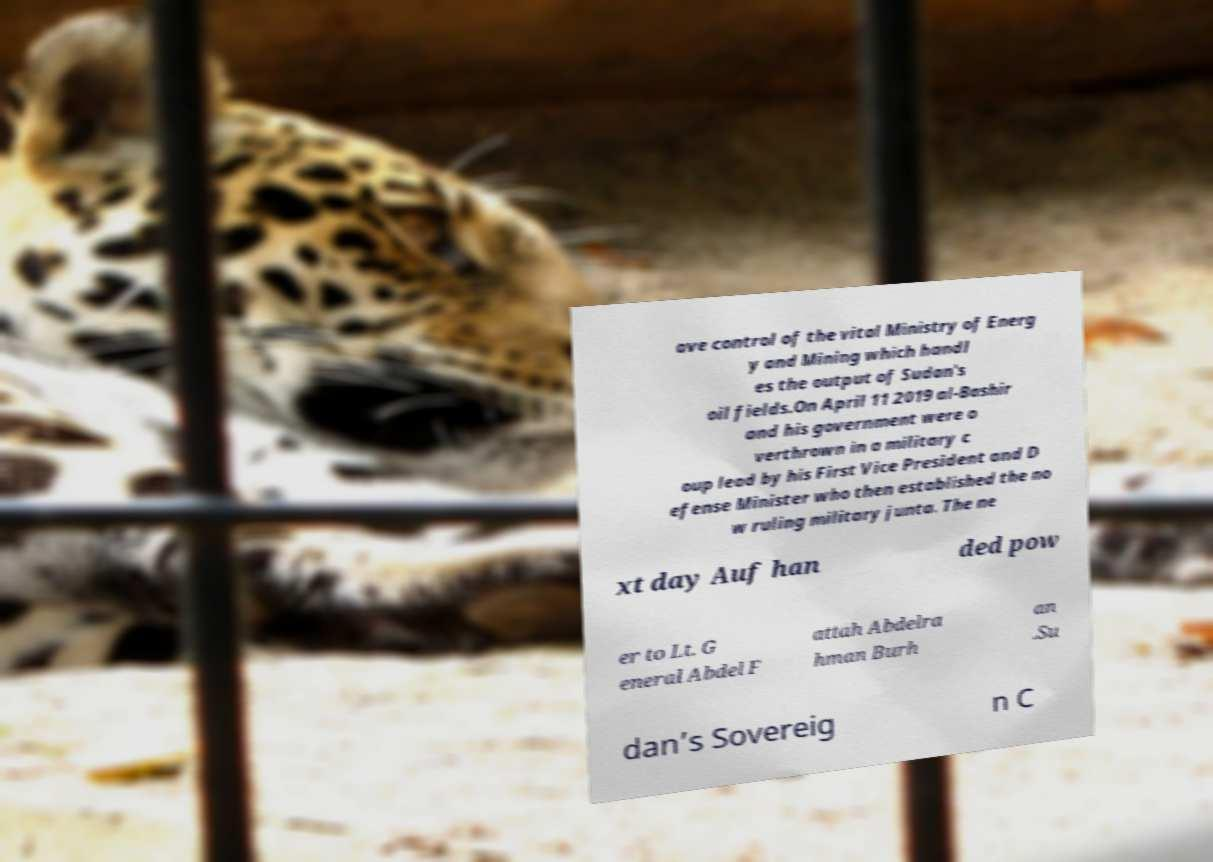Can you read and provide the text displayed in the image?This photo seems to have some interesting text. Can you extract and type it out for me? ave control of the vital Ministry of Energ y and Mining which handl es the output of Sudan's oil fields.On April 11 2019 al-Bashir and his government were o verthrown in a military c oup lead by his First Vice President and D efense Minister who then established the no w ruling military junta. The ne xt day Auf han ded pow er to Lt. G eneral Abdel F attah Abdelra hman Burh an .Su dan’s Sovereig n C 